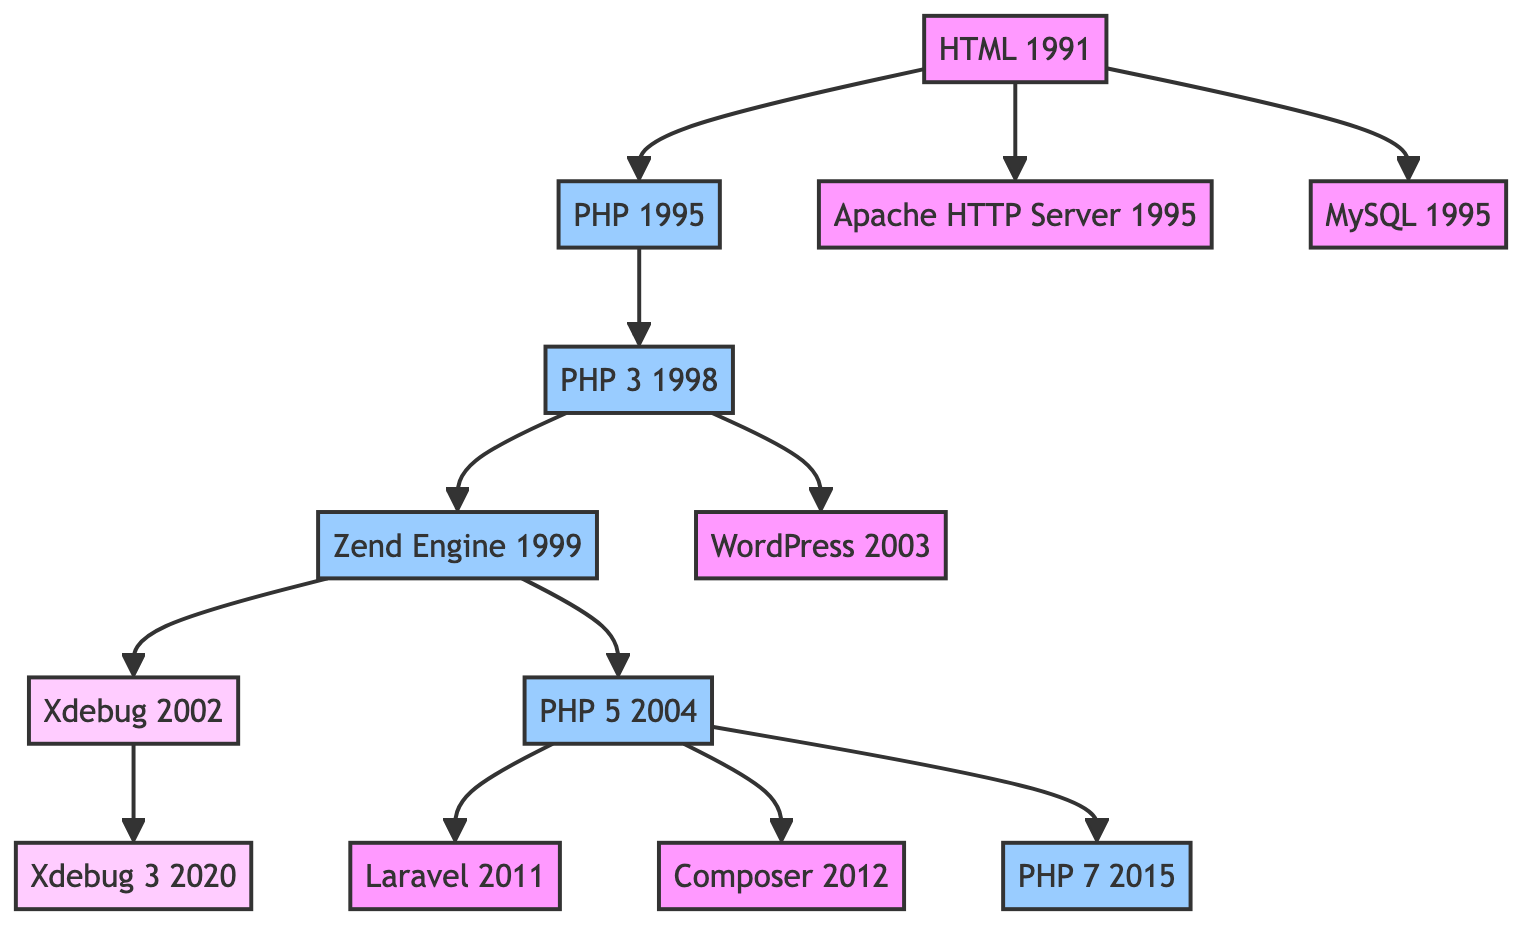What year was HTML introduced? The diagram indicates that HTML was introduced in 1991, and this information is clearly labeled next to the node representing HTML.
Answer: 1991 What are the two PHP milestones that occurred before 2000? By examining the diagram, the nodes for PHP 3 in 1998 and the Zend Engine in 1999 are identified as PHP milestones that occurred before the year 2000.
Answer: PHP 3, Zend Engine Which technology serves as a foundation for both PHP and MySQL? The diagram shows that both PHP and MySQL are directly connected to HTML, indicating that HTML serves as the foundational technology for both.
Answer: HTML How many key nodes link to PHP in the diagram? Counting the arrows or edges originating from the PHP node, we can determine that three nodes—PHP 3, WordPress, and PHP 5—link to PHP.
Answer: 3 What is the relationship between Xdebug and PHP 5? Xdebug is a descendant of the Zend Engine, which is a milestone reached after PHP 5 (since it improved upon PHP 4). Therefore, Xdebug is implemented after PHP 5 which directly improved PHP capabilities.
Answer: Descendant What key technology was introduced in 2002? The diagram labels Xdebug as the technology introduced in 2002.
Answer: Xdebug What order do the major PHP milestones occur from first to last? Following the flow of connections in the diagram, the major PHP milestones occur in the following order: PHP, PHP 3, Zend Engine, PHP 5, PHP 7.
Answer: PHP, PHP 3, Zend Engine, PHP 5, PHP 7 Which was introduced first, Laravel or Composer? By looking at the years associated with each milestone, Composer in 2012 and Laravel in 2011, it is evident that Laravel was introduced first.
Answer: Laravel What type of technology is Xdebug classified as? The diagram classifies Xdebug explicitly as a PHP extension, which indicates its purpose and association with PHP technology.
Answer: PHP extension 